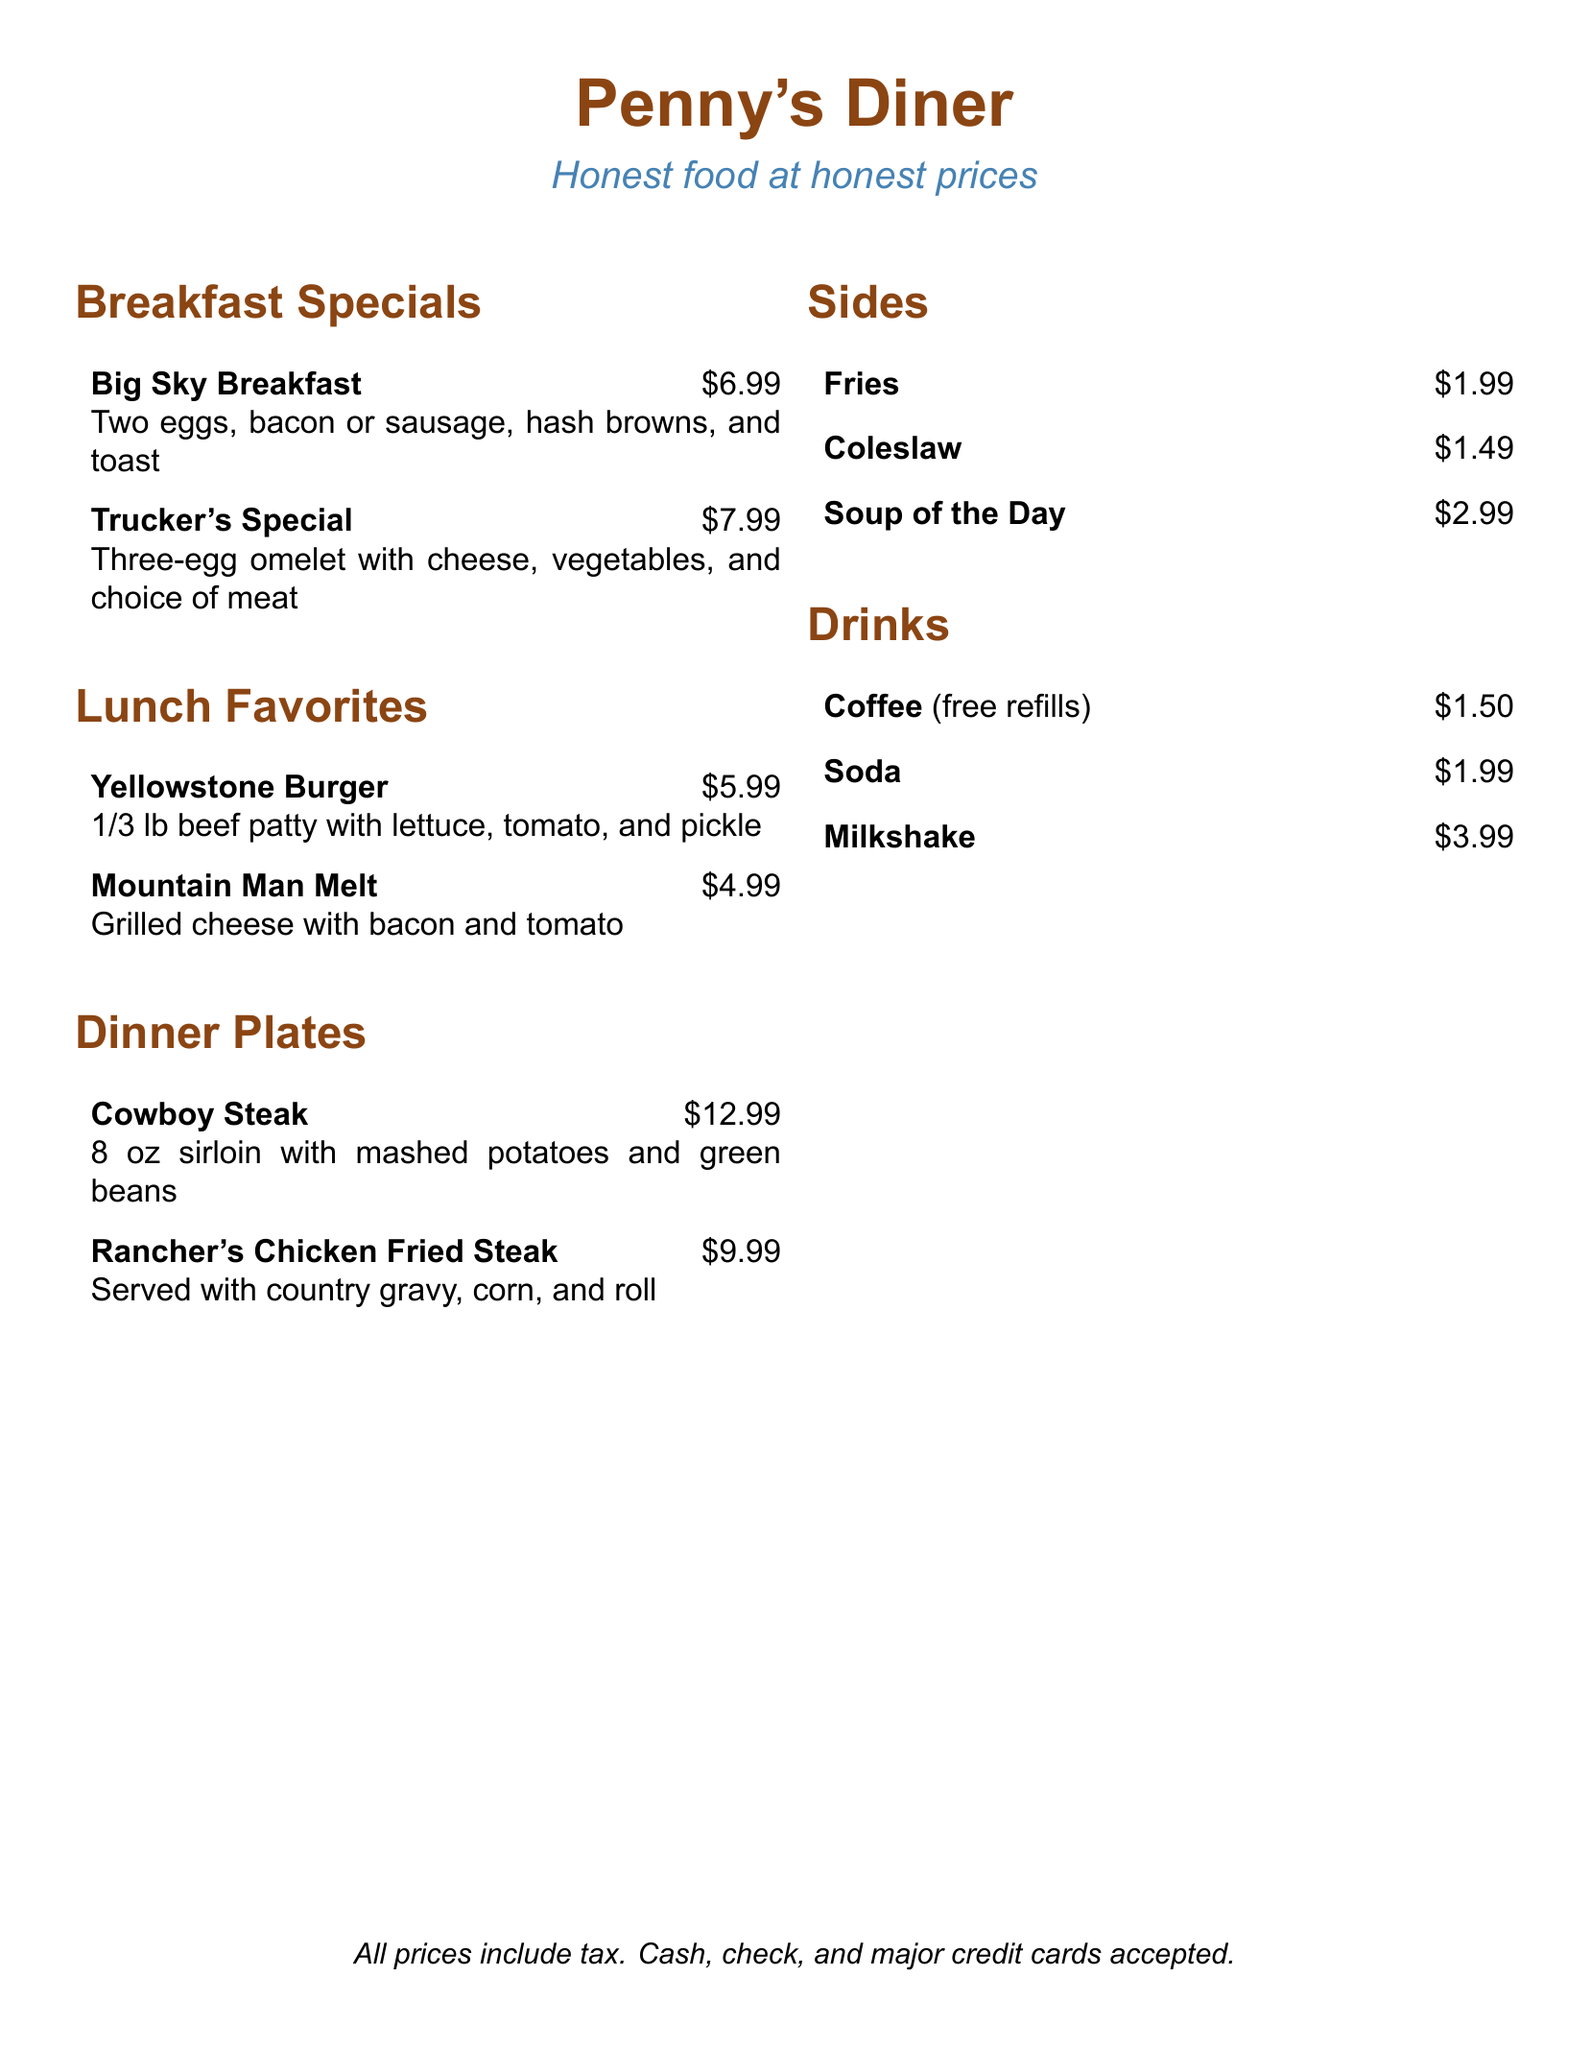what is the price of the Big Sky Breakfast? The price is listed directly next to the dish name in the Breakfast Specials section.
Answer: $6.99 what is included in the Trucker's Special? The description details the components included in this dish.
Answer: Three-egg omelet with cheese, vegetables, and choice of meat how much does a Yellowstone Burger cost? This price can be found next to the dish name in the Lunch Favorites section.
Answer: $5.99 what side dish costs the least? The price of each side dish is provided, making it easy to identify the lowest cost.
Answer: $1.49 how much is the Rancher's Chicken Fried Steak? The dinner plate prices are specified next to the menu items, including this one.
Answer: $9.99 how much are free refills of coffee? The drink prices are shown, and free refills apply specifically to the coffee.
Answer: $1.50 what is the total cost of a Mountain Man Melt with fries? This requires adding the prices of the two selected items from the menu.
Answer: $6.98 what type of meat is served with the Cowboy Steak? The description of the Cowboy Steak refers to the type of meat used in the dish.
Answer: Sirloin what drinks are available for less than $2? By reviewing the Drinks section, we can identify which items fit this price criterion.
Answer: Coffee, Soda 